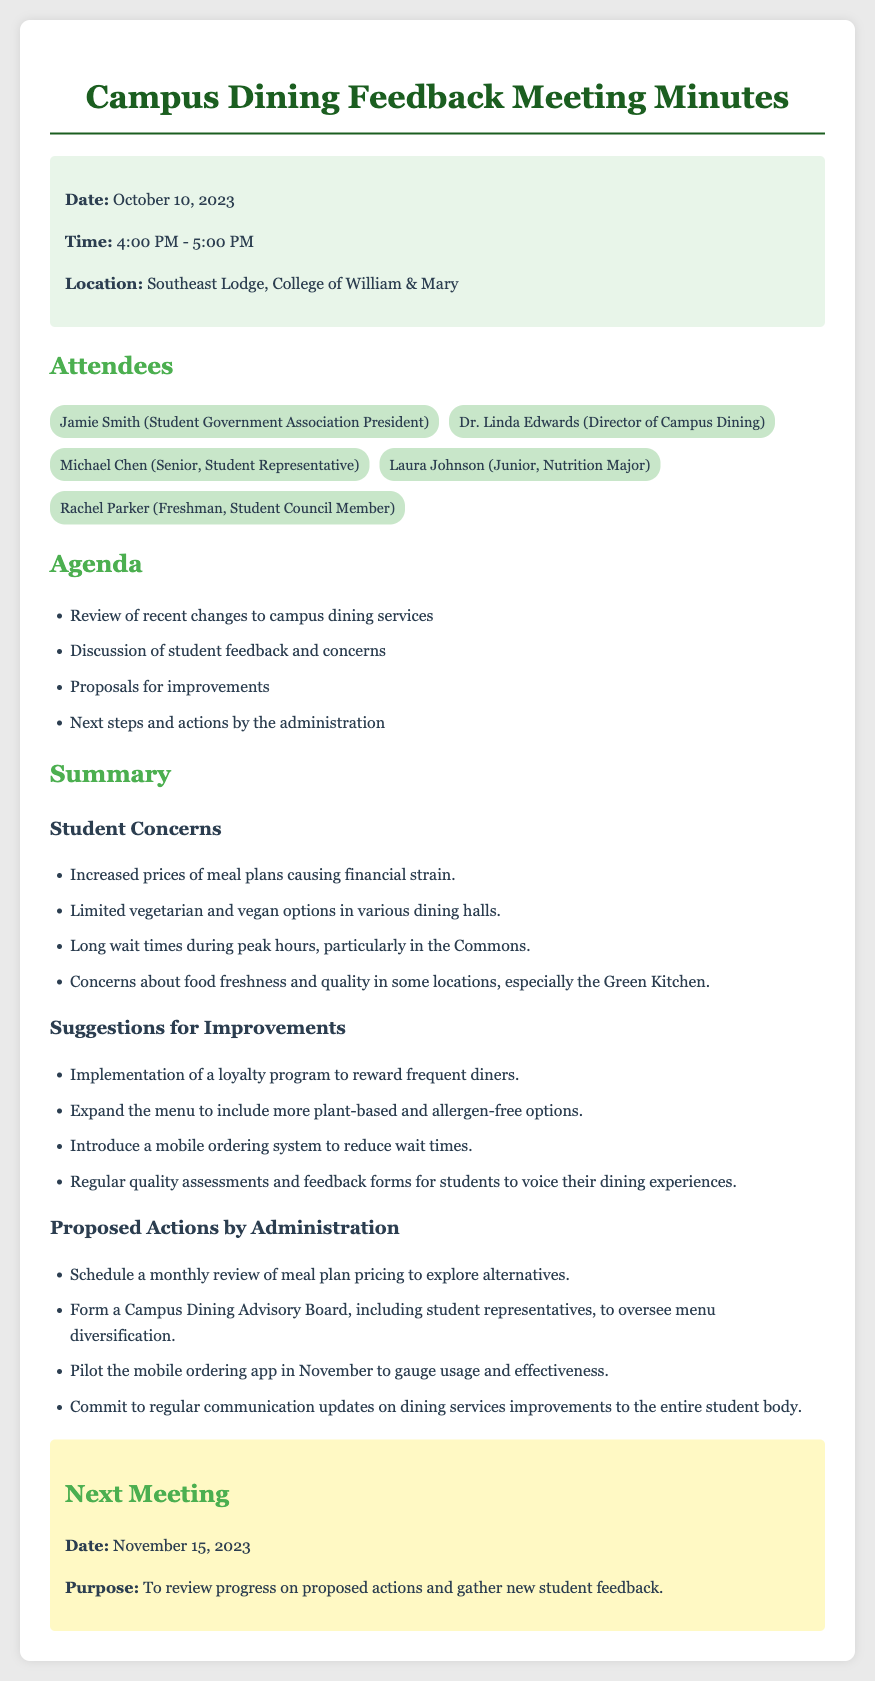What is the date of the meeting? The date of the meeting is specified in the document under the info section, which is October 10, 2023.
Answer: October 10, 2023 Who is the Director of Campus Dining? The Director of Campus Dining is mentioned in the attendees section of the document, which lists Dr. Linda Edwards.
Answer: Dr. Linda Edwards What is one student concern mentioned in the meeting? Several student concerns are listed in the summary section, one of which is the increased prices of meal plans causing financial strain.
Answer: Increased prices of meal plans How many proposals for improvements were suggested? The document lists four suggestions for improvements in the summary section under Suggestions for Improvements.
Answer: Four What is the purpose of the next meeting? The purpose of the next meeting is indicated in the next meeting section, which is to review progress on proposed actions and gather new student feedback.
Answer: To review progress on proposed actions and gather new student feedback When is the next meeting scheduled? The date for the next meeting is provided in the next meeting section, which is November 15, 2023.
Answer: November 15, 2023 What is one proposed action by the administration? The proposed actions by administration are listed; one example is to schedule a monthly review of meal plan pricing.
Answer: Schedule a monthly review of meal plan pricing Who is the student government association president? The document identifies Jamie Smith as the Student Government Association President in the attendees section.
Answer: Jamie Smith 